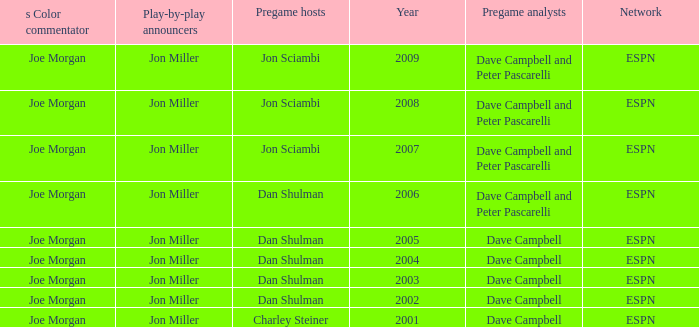Parse the table in full. {'header': ['s Color commentator', 'Play-by-play announcers', 'Pregame hosts', 'Year', 'Pregame analysts', 'Network'], 'rows': [['Joe Morgan', 'Jon Miller', 'Jon Sciambi', '2009', 'Dave Campbell and Peter Pascarelli', 'ESPN'], ['Joe Morgan', 'Jon Miller', 'Jon Sciambi', '2008', 'Dave Campbell and Peter Pascarelli', 'ESPN'], ['Joe Morgan', 'Jon Miller', 'Jon Sciambi', '2007', 'Dave Campbell and Peter Pascarelli', 'ESPN'], ['Joe Morgan', 'Jon Miller', 'Dan Shulman', '2006', 'Dave Campbell and Peter Pascarelli', 'ESPN'], ['Joe Morgan', 'Jon Miller', 'Dan Shulman', '2005', 'Dave Campbell', 'ESPN'], ['Joe Morgan', 'Jon Miller', 'Dan Shulman', '2004', 'Dave Campbell', 'ESPN'], ['Joe Morgan', 'Jon Miller', 'Dan Shulman', '2003', 'Dave Campbell', 'ESPN'], ['Joe Morgan', 'Jon Miller', 'Dan Shulman', '2002', 'Dave Campbell', 'ESPN'], ['Joe Morgan', 'Jon Miller', 'Charley Steiner', '2001', 'Dave Campbell', 'ESPN']]} Who is the s color commentator when the pregame host is jon sciambi? Joe Morgan, Joe Morgan, Joe Morgan. 